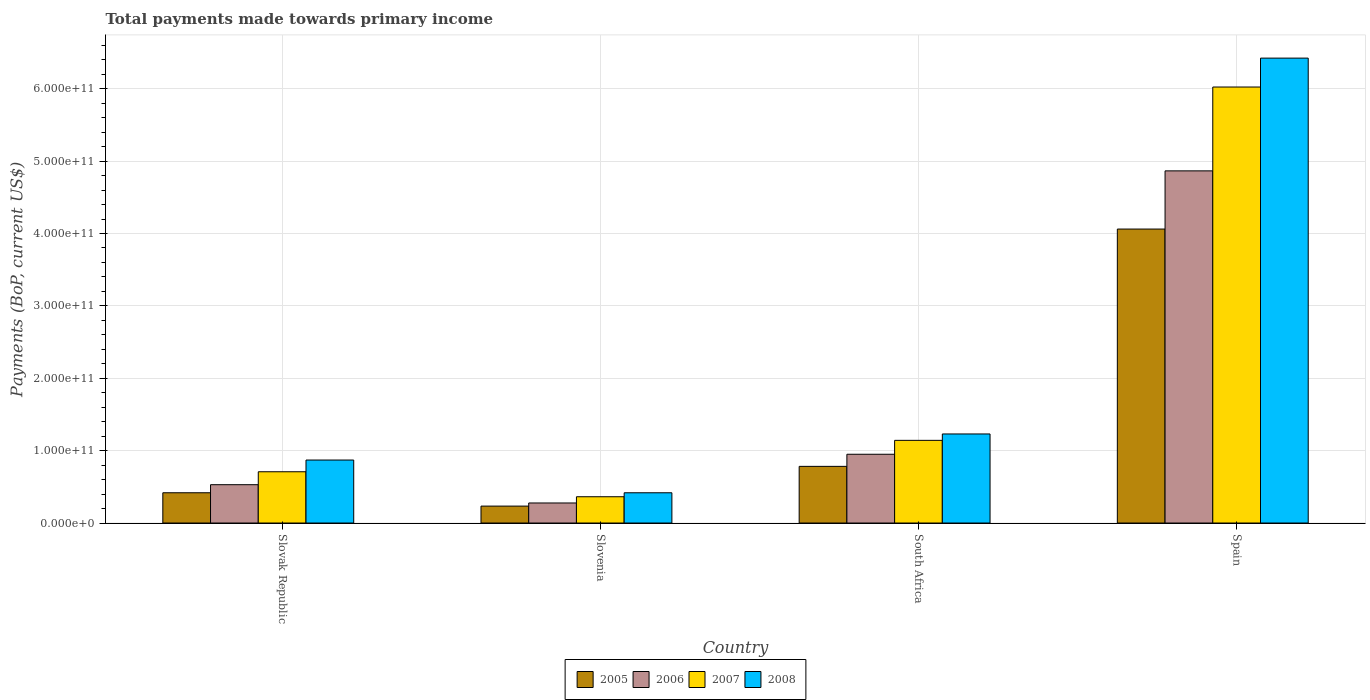How many bars are there on the 3rd tick from the right?
Keep it short and to the point. 4. What is the label of the 1st group of bars from the left?
Offer a very short reply. Slovak Republic. What is the total payments made towards primary income in 2005 in Spain?
Your response must be concise. 4.06e+11. Across all countries, what is the maximum total payments made towards primary income in 2005?
Provide a short and direct response. 4.06e+11. Across all countries, what is the minimum total payments made towards primary income in 2007?
Your response must be concise. 3.63e+1. In which country was the total payments made towards primary income in 2007 minimum?
Offer a terse response. Slovenia. What is the total total payments made towards primary income in 2008 in the graph?
Give a very brief answer. 8.94e+11. What is the difference between the total payments made towards primary income in 2006 in Slovenia and that in Spain?
Your response must be concise. -4.59e+11. What is the difference between the total payments made towards primary income in 2006 in Spain and the total payments made towards primary income in 2007 in Slovak Republic?
Your response must be concise. 4.16e+11. What is the average total payments made towards primary income in 2005 per country?
Keep it short and to the point. 1.37e+11. What is the difference between the total payments made towards primary income of/in 2005 and total payments made towards primary income of/in 2007 in South Africa?
Provide a short and direct response. -3.59e+1. In how many countries, is the total payments made towards primary income in 2008 greater than 100000000000 US$?
Your answer should be very brief. 2. What is the ratio of the total payments made towards primary income in 2006 in South Africa to that in Spain?
Offer a terse response. 0.2. Is the total payments made towards primary income in 2007 in South Africa less than that in Spain?
Provide a short and direct response. Yes. What is the difference between the highest and the second highest total payments made towards primary income in 2006?
Keep it short and to the point. 3.92e+11. What is the difference between the highest and the lowest total payments made towards primary income in 2007?
Keep it short and to the point. 5.66e+11. What does the 4th bar from the left in Spain represents?
Provide a short and direct response. 2008. How many bars are there?
Keep it short and to the point. 16. How many countries are there in the graph?
Provide a succinct answer. 4. What is the difference between two consecutive major ticks on the Y-axis?
Offer a terse response. 1.00e+11. Are the values on the major ticks of Y-axis written in scientific E-notation?
Provide a short and direct response. Yes. Where does the legend appear in the graph?
Make the answer very short. Bottom center. How many legend labels are there?
Keep it short and to the point. 4. What is the title of the graph?
Ensure brevity in your answer.  Total payments made towards primary income. What is the label or title of the X-axis?
Ensure brevity in your answer.  Country. What is the label or title of the Y-axis?
Your response must be concise. Payments (BoP, current US$). What is the Payments (BoP, current US$) in 2005 in Slovak Republic?
Your answer should be compact. 4.18e+1. What is the Payments (BoP, current US$) in 2006 in Slovak Republic?
Keep it short and to the point. 5.30e+1. What is the Payments (BoP, current US$) of 2007 in Slovak Republic?
Offer a very short reply. 7.08e+1. What is the Payments (BoP, current US$) in 2008 in Slovak Republic?
Your answer should be compact. 8.70e+1. What is the Payments (BoP, current US$) in 2005 in Slovenia?
Offer a terse response. 2.34e+1. What is the Payments (BoP, current US$) in 2006 in Slovenia?
Offer a terse response. 2.77e+1. What is the Payments (BoP, current US$) in 2007 in Slovenia?
Keep it short and to the point. 3.63e+1. What is the Payments (BoP, current US$) of 2008 in Slovenia?
Offer a very short reply. 4.18e+1. What is the Payments (BoP, current US$) in 2005 in South Africa?
Keep it short and to the point. 7.83e+1. What is the Payments (BoP, current US$) of 2006 in South Africa?
Make the answer very short. 9.50e+1. What is the Payments (BoP, current US$) in 2007 in South Africa?
Your response must be concise. 1.14e+11. What is the Payments (BoP, current US$) of 2008 in South Africa?
Your answer should be compact. 1.23e+11. What is the Payments (BoP, current US$) of 2005 in Spain?
Your answer should be very brief. 4.06e+11. What is the Payments (BoP, current US$) in 2006 in Spain?
Your response must be concise. 4.87e+11. What is the Payments (BoP, current US$) of 2007 in Spain?
Keep it short and to the point. 6.02e+11. What is the Payments (BoP, current US$) in 2008 in Spain?
Provide a succinct answer. 6.42e+11. Across all countries, what is the maximum Payments (BoP, current US$) in 2005?
Your answer should be very brief. 4.06e+11. Across all countries, what is the maximum Payments (BoP, current US$) in 2006?
Provide a succinct answer. 4.87e+11. Across all countries, what is the maximum Payments (BoP, current US$) of 2007?
Ensure brevity in your answer.  6.02e+11. Across all countries, what is the maximum Payments (BoP, current US$) in 2008?
Give a very brief answer. 6.42e+11. Across all countries, what is the minimum Payments (BoP, current US$) in 2005?
Offer a terse response. 2.34e+1. Across all countries, what is the minimum Payments (BoP, current US$) in 2006?
Ensure brevity in your answer.  2.77e+1. Across all countries, what is the minimum Payments (BoP, current US$) in 2007?
Your response must be concise. 3.63e+1. Across all countries, what is the minimum Payments (BoP, current US$) in 2008?
Keep it short and to the point. 4.18e+1. What is the total Payments (BoP, current US$) in 2005 in the graph?
Make the answer very short. 5.50e+11. What is the total Payments (BoP, current US$) of 2006 in the graph?
Provide a short and direct response. 6.62e+11. What is the total Payments (BoP, current US$) of 2007 in the graph?
Make the answer very short. 8.24e+11. What is the total Payments (BoP, current US$) in 2008 in the graph?
Offer a very short reply. 8.94e+11. What is the difference between the Payments (BoP, current US$) of 2005 in Slovak Republic and that in Slovenia?
Give a very brief answer. 1.84e+1. What is the difference between the Payments (BoP, current US$) of 2006 in Slovak Republic and that in Slovenia?
Your response must be concise. 2.53e+1. What is the difference between the Payments (BoP, current US$) in 2007 in Slovak Republic and that in Slovenia?
Provide a succinct answer. 3.45e+1. What is the difference between the Payments (BoP, current US$) of 2008 in Slovak Republic and that in Slovenia?
Provide a succinct answer. 4.52e+1. What is the difference between the Payments (BoP, current US$) of 2005 in Slovak Republic and that in South Africa?
Your response must be concise. -3.65e+1. What is the difference between the Payments (BoP, current US$) of 2006 in Slovak Republic and that in South Africa?
Provide a succinct answer. -4.21e+1. What is the difference between the Payments (BoP, current US$) in 2007 in Slovak Republic and that in South Africa?
Offer a terse response. -4.34e+1. What is the difference between the Payments (BoP, current US$) in 2008 in Slovak Republic and that in South Africa?
Offer a terse response. -3.60e+1. What is the difference between the Payments (BoP, current US$) of 2005 in Slovak Republic and that in Spain?
Your answer should be compact. -3.64e+11. What is the difference between the Payments (BoP, current US$) of 2006 in Slovak Republic and that in Spain?
Your response must be concise. -4.34e+11. What is the difference between the Payments (BoP, current US$) of 2007 in Slovak Republic and that in Spain?
Make the answer very short. -5.32e+11. What is the difference between the Payments (BoP, current US$) of 2008 in Slovak Republic and that in Spain?
Offer a very short reply. -5.55e+11. What is the difference between the Payments (BoP, current US$) of 2005 in Slovenia and that in South Africa?
Your answer should be compact. -5.49e+1. What is the difference between the Payments (BoP, current US$) in 2006 in Slovenia and that in South Africa?
Offer a very short reply. -6.73e+1. What is the difference between the Payments (BoP, current US$) in 2007 in Slovenia and that in South Africa?
Ensure brevity in your answer.  -7.79e+1. What is the difference between the Payments (BoP, current US$) of 2008 in Slovenia and that in South Africa?
Your response must be concise. -8.12e+1. What is the difference between the Payments (BoP, current US$) of 2005 in Slovenia and that in Spain?
Keep it short and to the point. -3.83e+11. What is the difference between the Payments (BoP, current US$) of 2006 in Slovenia and that in Spain?
Make the answer very short. -4.59e+11. What is the difference between the Payments (BoP, current US$) in 2007 in Slovenia and that in Spain?
Your answer should be very brief. -5.66e+11. What is the difference between the Payments (BoP, current US$) of 2008 in Slovenia and that in Spain?
Offer a very short reply. -6.00e+11. What is the difference between the Payments (BoP, current US$) in 2005 in South Africa and that in Spain?
Make the answer very short. -3.28e+11. What is the difference between the Payments (BoP, current US$) of 2006 in South Africa and that in Spain?
Make the answer very short. -3.92e+11. What is the difference between the Payments (BoP, current US$) in 2007 in South Africa and that in Spain?
Your answer should be very brief. -4.88e+11. What is the difference between the Payments (BoP, current US$) of 2008 in South Africa and that in Spain?
Keep it short and to the point. -5.19e+11. What is the difference between the Payments (BoP, current US$) in 2005 in Slovak Republic and the Payments (BoP, current US$) in 2006 in Slovenia?
Your response must be concise. 1.41e+1. What is the difference between the Payments (BoP, current US$) of 2005 in Slovak Republic and the Payments (BoP, current US$) of 2007 in Slovenia?
Your response must be concise. 5.50e+09. What is the difference between the Payments (BoP, current US$) of 2005 in Slovak Republic and the Payments (BoP, current US$) of 2008 in Slovenia?
Keep it short and to the point. 1.37e+07. What is the difference between the Payments (BoP, current US$) of 2006 in Slovak Republic and the Payments (BoP, current US$) of 2007 in Slovenia?
Keep it short and to the point. 1.66e+1. What is the difference between the Payments (BoP, current US$) in 2006 in Slovak Republic and the Payments (BoP, current US$) in 2008 in Slovenia?
Provide a short and direct response. 1.11e+1. What is the difference between the Payments (BoP, current US$) in 2007 in Slovak Republic and the Payments (BoP, current US$) in 2008 in Slovenia?
Keep it short and to the point. 2.90e+1. What is the difference between the Payments (BoP, current US$) in 2005 in Slovak Republic and the Payments (BoP, current US$) in 2006 in South Africa?
Keep it short and to the point. -5.32e+1. What is the difference between the Payments (BoP, current US$) in 2005 in Slovak Republic and the Payments (BoP, current US$) in 2007 in South Africa?
Provide a succinct answer. -7.24e+1. What is the difference between the Payments (BoP, current US$) of 2005 in Slovak Republic and the Payments (BoP, current US$) of 2008 in South Africa?
Offer a very short reply. -8.12e+1. What is the difference between the Payments (BoP, current US$) of 2006 in Slovak Republic and the Payments (BoP, current US$) of 2007 in South Africa?
Ensure brevity in your answer.  -6.13e+1. What is the difference between the Payments (BoP, current US$) of 2006 in Slovak Republic and the Payments (BoP, current US$) of 2008 in South Africa?
Keep it short and to the point. -7.01e+1. What is the difference between the Payments (BoP, current US$) of 2007 in Slovak Republic and the Payments (BoP, current US$) of 2008 in South Africa?
Keep it short and to the point. -5.22e+1. What is the difference between the Payments (BoP, current US$) in 2005 in Slovak Republic and the Payments (BoP, current US$) in 2006 in Spain?
Your response must be concise. -4.45e+11. What is the difference between the Payments (BoP, current US$) of 2005 in Slovak Republic and the Payments (BoP, current US$) of 2007 in Spain?
Give a very brief answer. -5.61e+11. What is the difference between the Payments (BoP, current US$) in 2005 in Slovak Republic and the Payments (BoP, current US$) in 2008 in Spain?
Your answer should be compact. -6.00e+11. What is the difference between the Payments (BoP, current US$) of 2006 in Slovak Republic and the Payments (BoP, current US$) of 2007 in Spain?
Provide a short and direct response. -5.49e+11. What is the difference between the Payments (BoP, current US$) in 2006 in Slovak Republic and the Payments (BoP, current US$) in 2008 in Spain?
Keep it short and to the point. -5.89e+11. What is the difference between the Payments (BoP, current US$) of 2007 in Slovak Republic and the Payments (BoP, current US$) of 2008 in Spain?
Make the answer very short. -5.71e+11. What is the difference between the Payments (BoP, current US$) of 2005 in Slovenia and the Payments (BoP, current US$) of 2006 in South Africa?
Make the answer very short. -7.16e+1. What is the difference between the Payments (BoP, current US$) in 2005 in Slovenia and the Payments (BoP, current US$) in 2007 in South Africa?
Ensure brevity in your answer.  -9.08e+1. What is the difference between the Payments (BoP, current US$) of 2005 in Slovenia and the Payments (BoP, current US$) of 2008 in South Africa?
Keep it short and to the point. -9.97e+1. What is the difference between the Payments (BoP, current US$) in 2006 in Slovenia and the Payments (BoP, current US$) in 2007 in South Africa?
Provide a short and direct response. -8.65e+1. What is the difference between the Payments (BoP, current US$) in 2006 in Slovenia and the Payments (BoP, current US$) in 2008 in South Africa?
Keep it short and to the point. -9.54e+1. What is the difference between the Payments (BoP, current US$) of 2007 in Slovenia and the Payments (BoP, current US$) of 2008 in South Africa?
Your answer should be compact. -8.67e+1. What is the difference between the Payments (BoP, current US$) of 2005 in Slovenia and the Payments (BoP, current US$) of 2006 in Spain?
Ensure brevity in your answer.  -4.63e+11. What is the difference between the Payments (BoP, current US$) in 2005 in Slovenia and the Payments (BoP, current US$) in 2007 in Spain?
Make the answer very short. -5.79e+11. What is the difference between the Payments (BoP, current US$) of 2005 in Slovenia and the Payments (BoP, current US$) of 2008 in Spain?
Offer a very short reply. -6.19e+11. What is the difference between the Payments (BoP, current US$) of 2006 in Slovenia and the Payments (BoP, current US$) of 2007 in Spain?
Offer a very short reply. -5.75e+11. What is the difference between the Payments (BoP, current US$) of 2006 in Slovenia and the Payments (BoP, current US$) of 2008 in Spain?
Provide a succinct answer. -6.15e+11. What is the difference between the Payments (BoP, current US$) in 2007 in Slovenia and the Payments (BoP, current US$) in 2008 in Spain?
Your response must be concise. -6.06e+11. What is the difference between the Payments (BoP, current US$) of 2005 in South Africa and the Payments (BoP, current US$) of 2006 in Spain?
Make the answer very short. -4.08e+11. What is the difference between the Payments (BoP, current US$) of 2005 in South Africa and the Payments (BoP, current US$) of 2007 in Spain?
Provide a succinct answer. -5.24e+11. What is the difference between the Payments (BoP, current US$) of 2005 in South Africa and the Payments (BoP, current US$) of 2008 in Spain?
Make the answer very short. -5.64e+11. What is the difference between the Payments (BoP, current US$) of 2006 in South Africa and the Payments (BoP, current US$) of 2007 in Spain?
Your response must be concise. -5.07e+11. What is the difference between the Payments (BoP, current US$) in 2006 in South Africa and the Payments (BoP, current US$) in 2008 in Spain?
Your answer should be very brief. -5.47e+11. What is the difference between the Payments (BoP, current US$) of 2007 in South Africa and the Payments (BoP, current US$) of 2008 in Spain?
Your answer should be compact. -5.28e+11. What is the average Payments (BoP, current US$) of 2005 per country?
Keep it short and to the point. 1.37e+11. What is the average Payments (BoP, current US$) of 2006 per country?
Provide a short and direct response. 1.66e+11. What is the average Payments (BoP, current US$) of 2007 per country?
Provide a short and direct response. 2.06e+11. What is the average Payments (BoP, current US$) of 2008 per country?
Make the answer very short. 2.24e+11. What is the difference between the Payments (BoP, current US$) of 2005 and Payments (BoP, current US$) of 2006 in Slovak Republic?
Your answer should be very brief. -1.11e+1. What is the difference between the Payments (BoP, current US$) of 2005 and Payments (BoP, current US$) of 2007 in Slovak Republic?
Ensure brevity in your answer.  -2.90e+1. What is the difference between the Payments (BoP, current US$) in 2005 and Payments (BoP, current US$) in 2008 in Slovak Republic?
Provide a short and direct response. -4.52e+1. What is the difference between the Payments (BoP, current US$) of 2006 and Payments (BoP, current US$) of 2007 in Slovak Republic?
Make the answer very short. -1.79e+1. What is the difference between the Payments (BoP, current US$) in 2006 and Payments (BoP, current US$) in 2008 in Slovak Republic?
Your answer should be very brief. -3.41e+1. What is the difference between the Payments (BoP, current US$) of 2007 and Payments (BoP, current US$) of 2008 in Slovak Republic?
Keep it short and to the point. -1.62e+1. What is the difference between the Payments (BoP, current US$) in 2005 and Payments (BoP, current US$) in 2006 in Slovenia?
Your answer should be compact. -4.30e+09. What is the difference between the Payments (BoP, current US$) of 2005 and Payments (BoP, current US$) of 2007 in Slovenia?
Give a very brief answer. -1.29e+1. What is the difference between the Payments (BoP, current US$) of 2005 and Payments (BoP, current US$) of 2008 in Slovenia?
Ensure brevity in your answer.  -1.84e+1. What is the difference between the Payments (BoP, current US$) in 2006 and Payments (BoP, current US$) in 2007 in Slovenia?
Provide a succinct answer. -8.63e+09. What is the difference between the Payments (BoP, current US$) in 2006 and Payments (BoP, current US$) in 2008 in Slovenia?
Make the answer very short. -1.41e+1. What is the difference between the Payments (BoP, current US$) in 2007 and Payments (BoP, current US$) in 2008 in Slovenia?
Your response must be concise. -5.49e+09. What is the difference between the Payments (BoP, current US$) of 2005 and Payments (BoP, current US$) of 2006 in South Africa?
Your answer should be very brief. -1.67e+1. What is the difference between the Payments (BoP, current US$) in 2005 and Payments (BoP, current US$) in 2007 in South Africa?
Your answer should be compact. -3.59e+1. What is the difference between the Payments (BoP, current US$) in 2005 and Payments (BoP, current US$) in 2008 in South Africa?
Provide a short and direct response. -4.48e+1. What is the difference between the Payments (BoP, current US$) of 2006 and Payments (BoP, current US$) of 2007 in South Africa?
Keep it short and to the point. -1.92e+1. What is the difference between the Payments (BoP, current US$) in 2006 and Payments (BoP, current US$) in 2008 in South Africa?
Offer a very short reply. -2.80e+1. What is the difference between the Payments (BoP, current US$) in 2007 and Payments (BoP, current US$) in 2008 in South Africa?
Keep it short and to the point. -8.82e+09. What is the difference between the Payments (BoP, current US$) of 2005 and Payments (BoP, current US$) of 2006 in Spain?
Provide a short and direct response. -8.04e+1. What is the difference between the Payments (BoP, current US$) of 2005 and Payments (BoP, current US$) of 2007 in Spain?
Offer a terse response. -1.96e+11. What is the difference between the Payments (BoP, current US$) in 2005 and Payments (BoP, current US$) in 2008 in Spain?
Ensure brevity in your answer.  -2.36e+11. What is the difference between the Payments (BoP, current US$) of 2006 and Payments (BoP, current US$) of 2007 in Spain?
Offer a terse response. -1.16e+11. What is the difference between the Payments (BoP, current US$) of 2006 and Payments (BoP, current US$) of 2008 in Spain?
Give a very brief answer. -1.56e+11. What is the difference between the Payments (BoP, current US$) of 2007 and Payments (BoP, current US$) of 2008 in Spain?
Provide a short and direct response. -3.99e+1. What is the ratio of the Payments (BoP, current US$) in 2005 in Slovak Republic to that in Slovenia?
Offer a terse response. 1.79. What is the ratio of the Payments (BoP, current US$) of 2006 in Slovak Republic to that in Slovenia?
Give a very brief answer. 1.91. What is the ratio of the Payments (BoP, current US$) of 2007 in Slovak Republic to that in Slovenia?
Offer a terse response. 1.95. What is the ratio of the Payments (BoP, current US$) in 2008 in Slovak Republic to that in Slovenia?
Your response must be concise. 2.08. What is the ratio of the Payments (BoP, current US$) of 2005 in Slovak Republic to that in South Africa?
Offer a terse response. 0.53. What is the ratio of the Payments (BoP, current US$) of 2006 in Slovak Republic to that in South Africa?
Ensure brevity in your answer.  0.56. What is the ratio of the Payments (BoP, current US$) in 2007 in Slovak Republic to that in South Africa?
Your response must be concise. 0.62. What is the ratio of the Payments (BoP, current US$) of 2008 in Slovak Republic to that in South Africa?
Provide a short and direct response. 0.71. What is the ratio of the Payments (BoP, current US$) in 2005 in Slovak Republic to that in Spain?
Offer a very short reply. 0.1. What is the ratio of the Payments (BoP, current US$) in 2006 in Slovak Republic to that in Spain?
Offer a terse response. 0.11. What is the ratio of the Payments (BoP, current US$) in 2007 in Slovak Republic to that in Spain?
Provide a short and direct response. 0.12. What is the ratio of the Payments (BoP, current US$) of 2008 in Slovak Republic to that in Spain?
Make the answer very short. 0.14. What is the ratio of the Payments (BoP, current US$) in 2005 in Slovenia to that in South Africa?
Offer a very short reply. 0.3. What is the ratio of the Payments (BoP, current US$) of 2006 in Slovenia to that in South Africa?
Your response must be concise. 0.29. What is the ratio of the Payments (BoP, current US$) of 2007 in Slovenia to that in South Africa?
Offer a very short reply. 0.32. What is the ratio of the Payments (BoP, current US$) in 2008 in Slovenia to that in South Africa?
Ensure brevity in your answer.  0.34. What is the ratio of the Payments (BoP, current US$) of 2005 in Slovenia to that in Spain?
Your answer should be very brief. 0.06. What is the ratio of the Payments (BoP, current US$) in 2006 in Slovenia to that in Spain?
Your answer should be compact. 0.06. What is the ratio of the Payments (BoP, current US$) in 2007 in Slovenia to that in Spain?
Your answer should be very brief. 0.06. What is the ratio of the Payments (BoP, current US$) in 2008 in Slovenia to that in Spain?
Make the answer very short. 0.07. What is the ratio of the Payments (BoP, current US$) of 2005 in South Africa to that in Spain?
Make the answer very short. 0.19. What is the ratio of the Payments (BoP, current US$) in 2006 in South Africa to that in Spain?
Give a very brief answer. 0.2. What is the ratio of the Payments (BoP, current US$) in 2007 in South Africa to that in Spain?
Provide a short and direct response. 0.19. What is the ratio of the Payments (BoP, current US$) of 2008 in South Africa to that in Spain?
Offer a very short reply. 0.19. What is the difference between the highest and the second highest Payments (BoP, current US$) of 2005?
Make the answer very short. 3.28e+11. What is the difference between the highest and the second highest Payments (BoP, current US$) of 2006?
Your answer should be compact. 3.92e+11. What is the difference between the highest and the second highest Payments (BoP, current US$) of 2007?
Make the answer very short. 4.88e+11. What is the difference between the highest and the second highest Payments (BoP, current US$) in 2008?
Provide a short and direct response. 5.19e+11. What is the difference between the highest and the lowest Payments (BoP, current US$) in 2005?
Provide a succinct answer. 3.83e+11. What is the difference between the highest and the lowest Payments (BoP, current US$) in 2006?
Give a very brief answer. 4.59e+11. What is the difference between the highest and the lowest Payments (BoP, current US$) in 2007?
Give a very brief answer. 5.66e+11. What is the difference between the highest and the lowest Payments (BoP, current US$) of 2008?
Your response must be concise. 6.00e+11. 